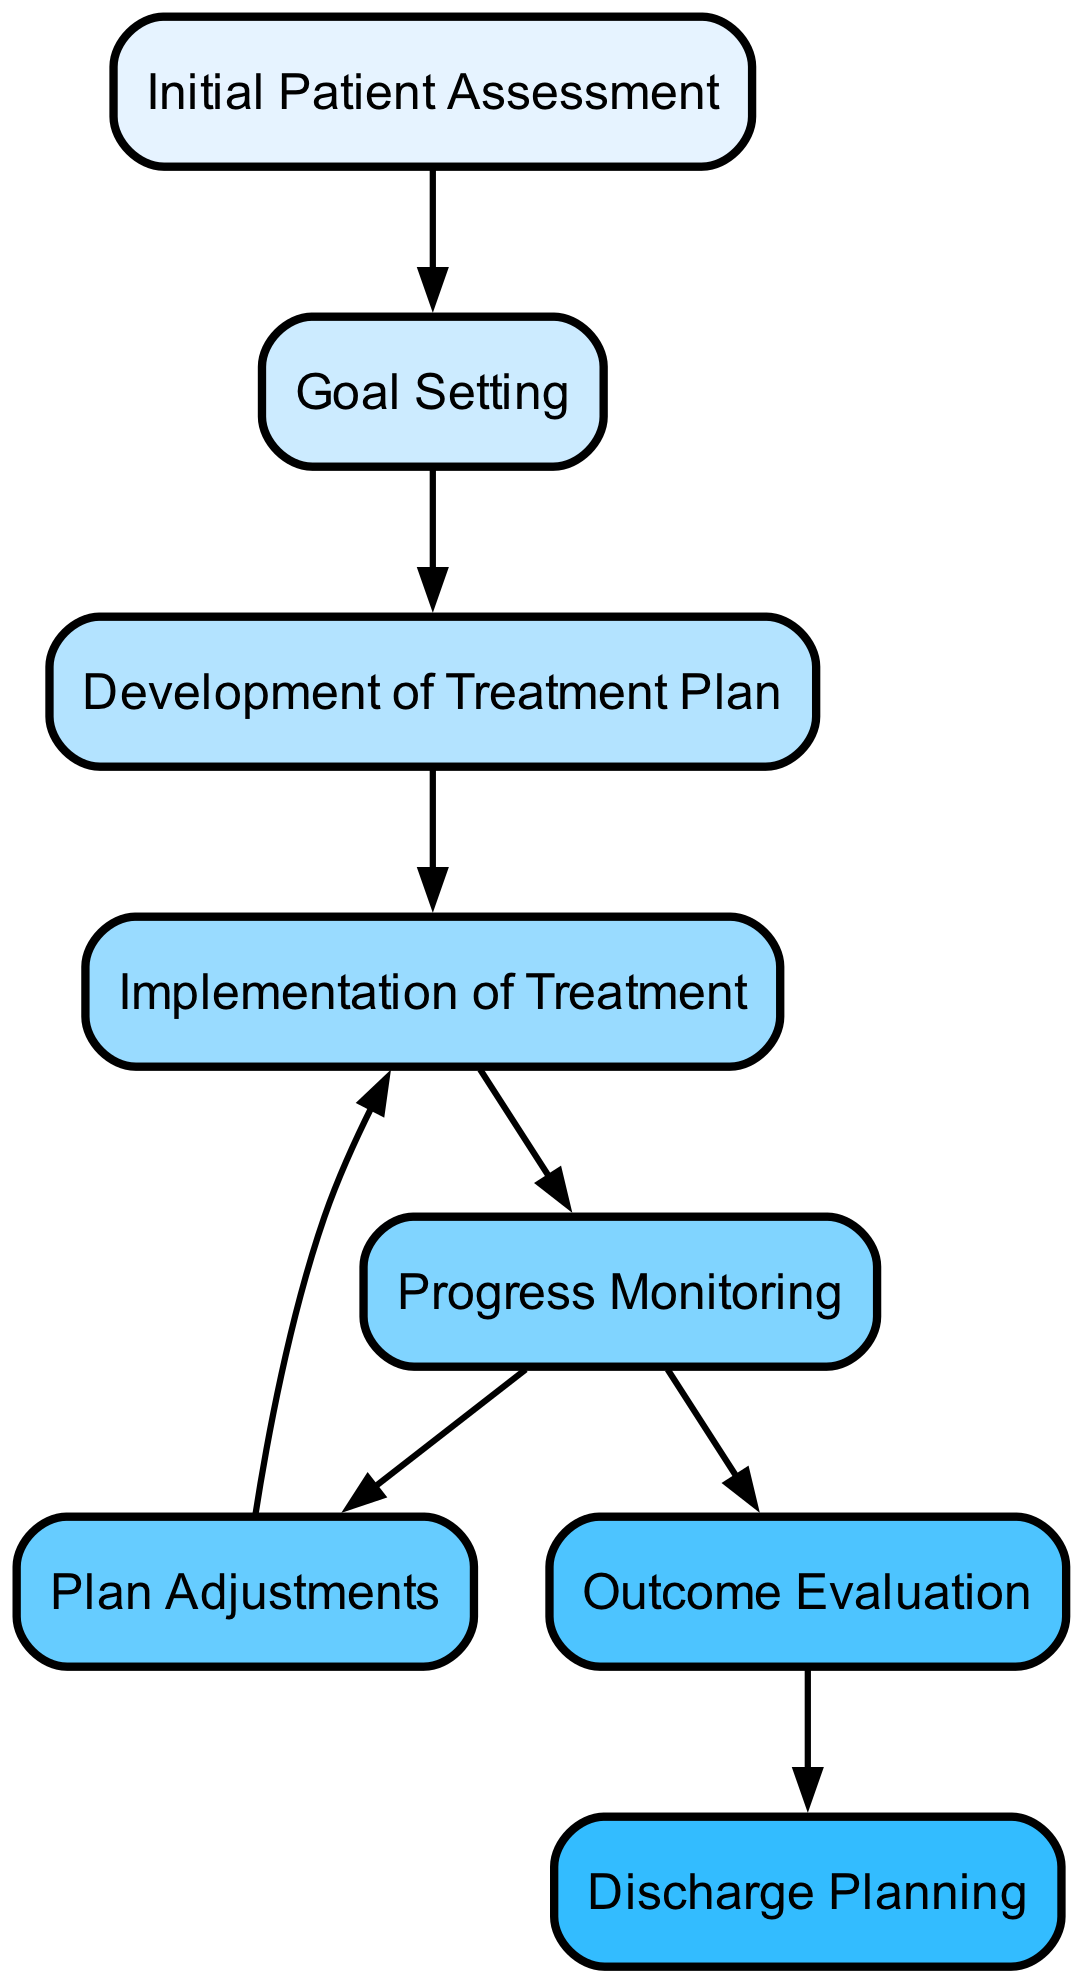What is the starting point of the rehabilitation process? The starting point is represented by the node "Assessment," indicating that the initial patient assessment is the first step in the process.
Answer: Initial Patient Assessment How many nodes are present in the diagram? The diagram consists of 8 nodes, each representing a key component of the rehabilitation process.
Answer: 8 Which node comes after "Goal Setting"? The node that follows "Goal Setting" is "Treatment Plan," indicating that once goals are established, a treatment plan is developed.
Answer: Development of Treatment Plan What is the endpoint of the rehabilitation plan process? The endpoint is depicted by the node "Discharge Planning," which signifies that the final step in the process is to plan for the patient's discharge.
Answer: Discharge Planning How many edges connect to the "Progress Monitoring" node? The "Progress Monitoring" node has 2 edges connecting to it, leading to "Adjustments" and "Outcome Evaluation," illustrating that progress monitoring influences both adjustments to the treatment plan and the evaluation of outcomes.
Answer: 2 What relationship exists between "Outcome Evaluation" and "Discharge Planning"? The relationship is direct, as "Outcome Evaluation" leads to "Discharge Planning," suggesting that evaluating outcomes is a prerequisite for planning patient discharge.
Answer: Direct relationship If a plan adjustment is made, which node is revisited? If a plan adjustment occurs, the diagram indicates that the process revisits the "Implementation" node, showing that treatment must be applied again following adjustments.
Answer: Implementation Which node has outgoing edges to exactly two other nodes? The "Progress Monitoring" node has outgoing edges to two other nodes: "Adjustments" and "Outcome Evaluation," highlighting that progress monitoring informs both aspects of the rehabilitation process.
Answer: Progress Monitoring 